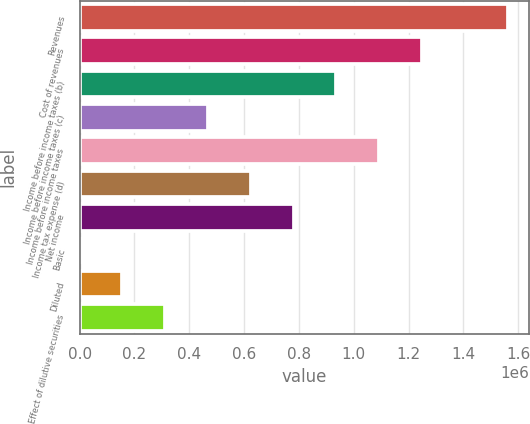Convert chart to OTSL. <chart><loc_0><loc_0><loc_500><loc_500><bar_chart><fcel>Revenues<fcel>Cost of revenues<fcel>Income before income taxes (b)<fcel>Income before income taxes (c)<fcel>Income before income taxes<fcel>Income tax expense (d)<fcel>Net income<fcel>Basic<fcel>Diluted<fcel>Effect of dilutive securities<nl><fcel>1.56127e+06<fcel>1.24902e+06<fcel>936764<fcel>468382<fcel>1.09289e+06<fcel>624509<fcel>780637<fcel>0.37<fcel>156128<fcel>312255<nl></chart> 